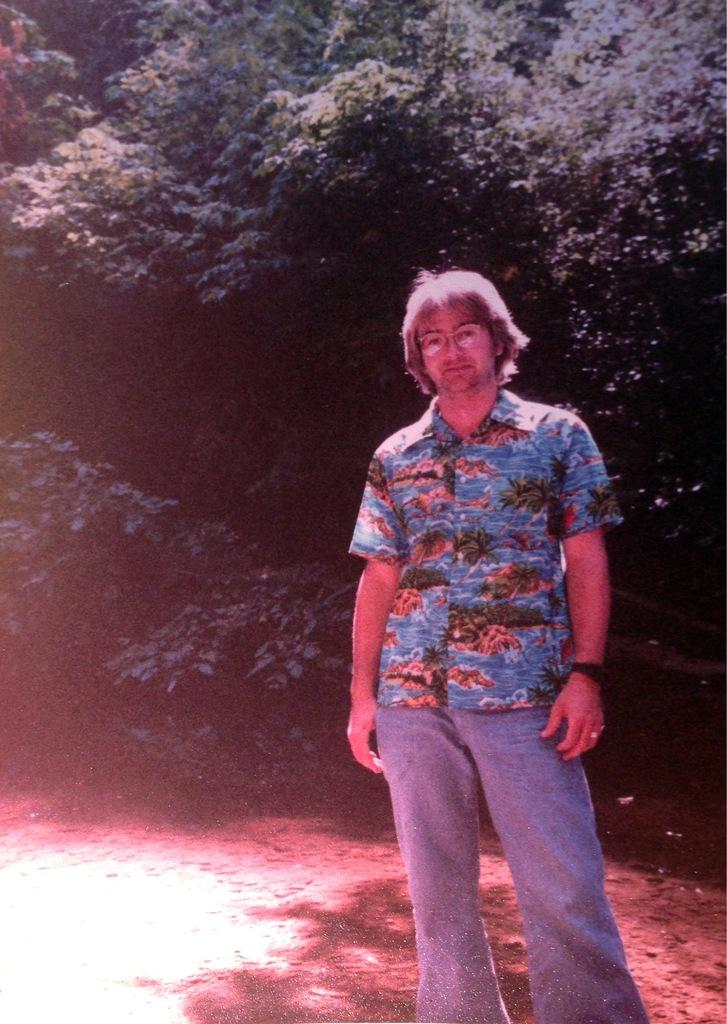What is the main subject of the image? There is a man standing in the image. What accessories is the man wearing? The man is wearing glasses and a watch. What can be seen in the background of the image? There are trees visible behind the man. man. What type of breakfast is the man eating in the image? There is no breakfast present in the image; the man is simply standing and wearing glasses and a watch. 